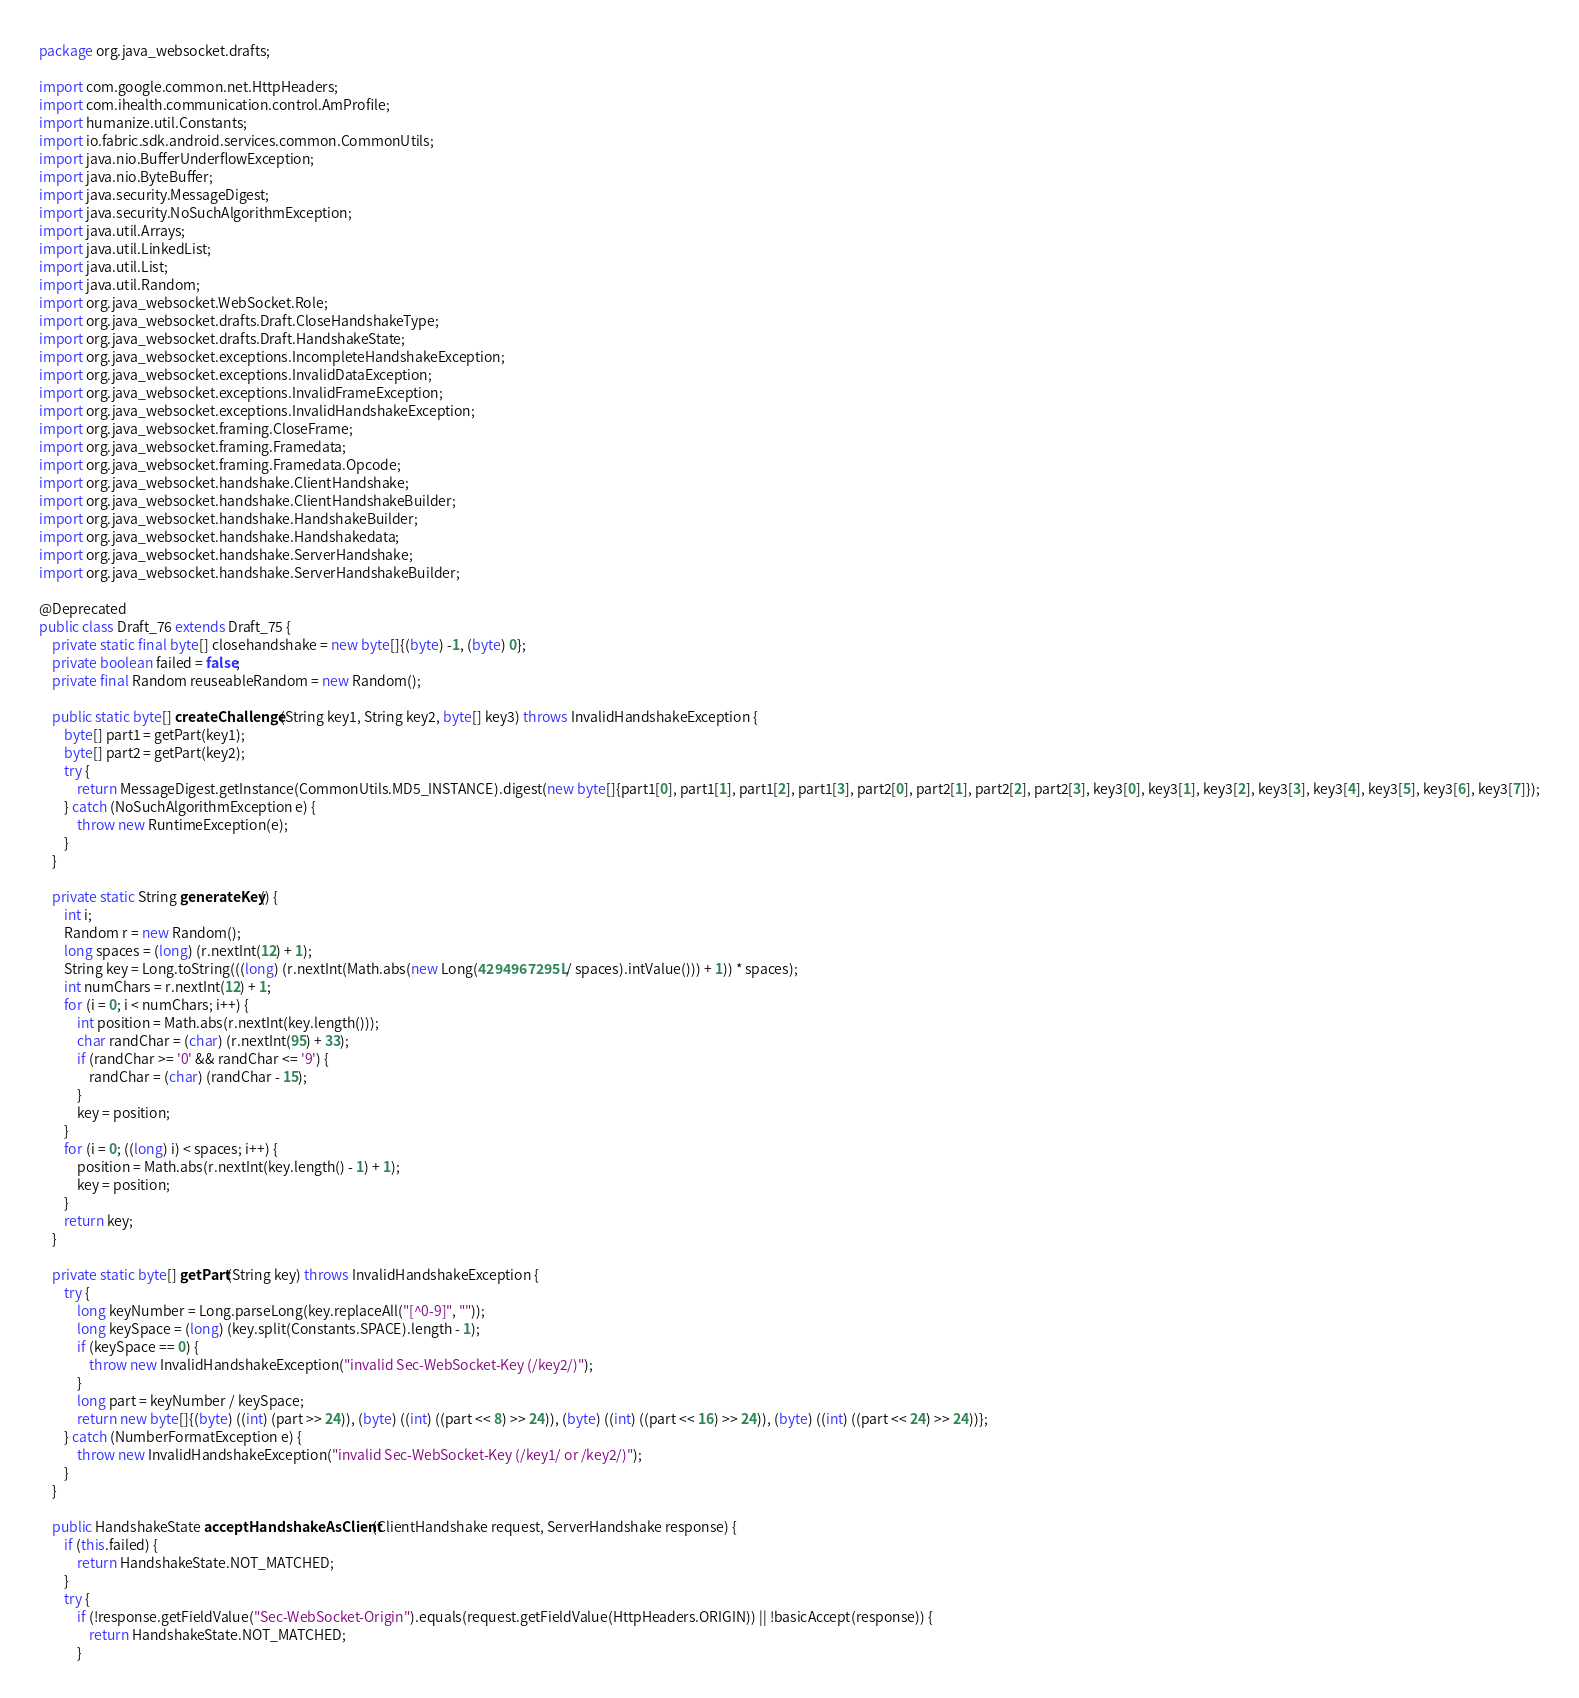Convert code to text. <code><loc_0><loc_0><loc_500><loc_500><_Java_>package org.java_websocket.drafts;

import com.google.common.net.HttpHeaders;
import com.ihealth.communication.control.AmProfile;
import humanize.util.Constants;
import io.fabric.sdk.android.services.common.CommonUtils;
import java.nio.BufferUnderflowException;
import java.nio.ByteBuffer;
import java.security.MessageDigest;
import java.security.NoSuchAlgorithmException;
import java.util.Arrays;
import java.util.LinkedList;
import java.util.List;
import java.util.Random;
import org.java_websocket.WebSocket.Role;
import org.java_websocket.drafts.Draft.CloseHandshakeType;
import org.java_websocket.drafts.Draft.HandshakeState;
import org.java_websocket.exceptions.IncompleteHandshakeException;
import org.java_websocket.exceptions.InvalidDataException;
import org.java_websocket.exceptions.InvalidFrameException;
import org.java_websocket.exceptions.InvalidHandshakeException;
import org.java_websocket.framing.CloseFrame;
import org.java_websocket.framing.Framedata;
import org.java_websocket.framing.Framedata.Opcode;
import org.java_websocket.handshake.ClientHandshake;
import org.java_websocket.handshake.ClientHandshakeBuilder;
import org.java_websocket.handshake.HandshakeBuilder;
import org.java_websocket.handshake.Handshakedata;
import org.java_websocket.handshake.ServerHandshake;
import org.java_websocket.handshake.ServerHandshakeBuilder;

@Deprecated
public class Draft_76 extends Draft_75 {
    private static final byte[] closehandshake = new byte[]{(byte) -1, (byte) 0};
    private boolean failed = false;
    private final Random reuseableRandom = new Random();

    public static byte[] createChallenge(String key1, String key2, byte[] key3) throws InvalidHandshakeException {
        byte[] part1 = getPart(key1);
        byte[] part2 = getPart(key2);
        try {
            return MessageDigest.getInstance(CommonUtils.MD5_INSTANCE).digest(new byte[]{part1[0], part1[1], part1[2], part1[3], part2[0], part2[1], part2[2], part2[3], key3[0], key3[1], key3[2], key3[3], key3[4], key3[5], key3[6], key3[7]});
        } catch (NoSuchAlgorithmException e) {
            throw new RuntimeException(e);
        }
    }

    private static String generateKey() {
        int i;
        Random r = new Random();
        long spaces = (long) (r.nextInt(12) + 1);
        String key = Long.toString(((long) (r.nextInt(Math.abs(new Long(4294967295L / spaces).intValue())) + 1)) * spaces);
        int numChars = r.nextInt(12) + 1;
        for (i = 0; i < numChars; i++) {
            int position = Math.abs(r.nextInt(key.length()));
            char randChar = (char) (r.nextInt(95) + 33);
            if (randChar >= '0' && randChar <= '9') {
                randChar = (char) (randChar - 15);
            }
            key = position;
        }
        for (i = 0; ((long) i) < spaces; i++) {
            position = Math.abs(r.nextInt(key.length() - 1) + 1);
            key = position;
        }
        return key;
    }

    private static byte[] getPart(String key) throws InvalidHandshakeException {
        try {
            long keyNumber = Long.parseLong(key.replaceAll("[^0-9]", ""));
            long keySpace = (long) (key.split(Constants.SPACE).length - 1);
            if (keySpace == 0) {
                throw new InvalidHandshakeException("invalid Sec-WebSocket-Key (/key2/)");
            }
            long part = keyNumber / keySpace;
            return new byte[]{(byte) ((int) (part >> 24)), (byte) ((int) ((part << 8) >> 24)), (byte) ((int) ((part << 16) >> 24)), (byte) ((int) ((part << 24) >> 24))};
        } catch (NumberFormatException e) {
            throw new InvalidHandshakeException("invalid Sec-WebSocket-Key (/key1/ or /key2/)");
        }
    }

    public HandshakeState acceptHandshakeAsClient(ClientHandshake request, ServerHandshake response) {
        if (this.failed) {
            return HandshakeState.NOT_MATCHED;
        }
        try {
            if (!response.getFieldValue("Sec-WebSocket-Origin").equals(request.getFieldValue(HttpHeaders.ORIGIN)) || !basicAccept(response)) {
                return HandshakeState.NOT_MATCHED;
            }</code> 